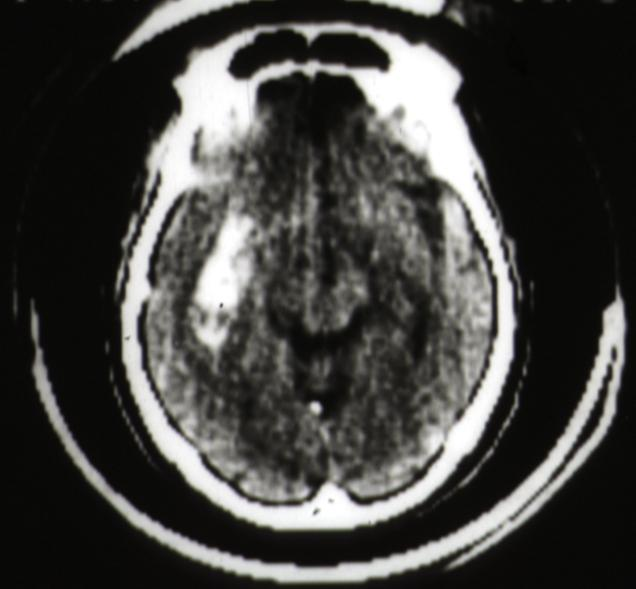does this image show cat scan putamen hemorrhage?
Answer the question using a single word or phrase. Yes 